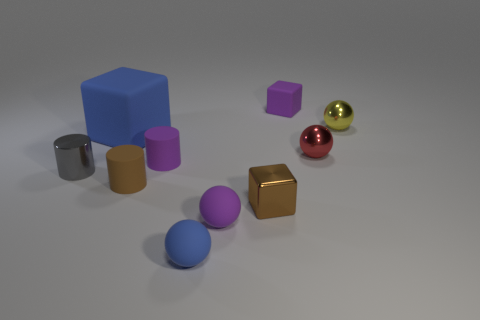Does the brown block have the same size as the red shiny object?
Ensure brevity in your answer.  Yes. What number of other things are the same size as the purple cylinder?
Provide a succinct answer. 8. Does the big matte thing have the same color as the tiny metallic cube?
Your answer should be compact. No. The small purple matte thing that is in front of the metallic object on the left side of the rubber cube to the left of the tiny purple cube is what shape?
Your answer should be compact. Sphere. What number of things are small shiny objects that are on the right side of the small blue rubber sphere or purple objects that are behind the yellow thing?
Offer a very short reply. 4. How big is the blue rubber object in front of the small purple cylinder that is on the right side of the small brown rubber object?
Ensure brevity in your answer.  Small. There is a small cube that is in front of the purple rubber cube; does it have the same color as the large rubber object?
Offer a very short reply. No. Are there any purple matte things of the same shape as the red metal thing?
Provide a short and direct response. Yes. The rubber cube that is the same size as the yellow shiny ball is what color?
Make the answer very short. Purple. There is a thing that is behind the yellow object; how big is it?
Make the answer very short. Small. 